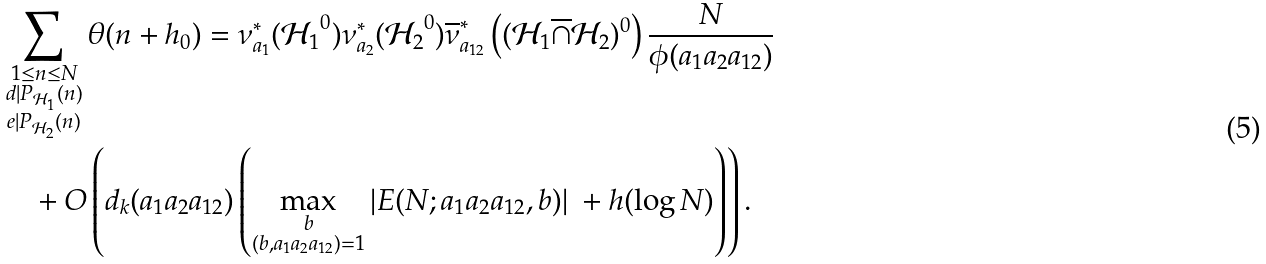Convert formula to latex. <formula><loc_0><loc_0><loc_500><loc_500>& \sum _ { \substack { 1 \leq n \leq N \\ d | P _ { \mathcal { H } _ { 1 } } ( n ) \\ e | P _ { \mathcal { H } _ { 2 } } ( n ) } } \theta ( n + h _ { 0 } ) = \nu _ { a _ { 1 } } ^ { * } ( { \mathcal { H } _ { 1 } } ^ { 0 } ) \nu _ { a _ { 2 } } ^ { * } ( { \mathcal { H } _ { 2 } } ^ { 0 } ) \overline { \nu } _ { a _ { 1 2 } } ^ { * } \left ( ( \mathcal { H } _ { 1 } \overline { \cap } \mathcal { H } _ { 2 } ) ^ { 0 } \right ) \frac { N } { \phi ( a _ { 1 } a _ { 2 } a _ { 1 2 } ) } \\ & \quad + O \left ( d _ { k } ( a _ { 1 } a _ { 2 } a _ { 1 2 } ) \left ( \max _ { \substack { b \\ ( b , a _ { 1 } a _ { 2 } a _ { 1 2 } ) = 1 } } \left | E ( N ; a _ { 1 } a _ { 2 } a _ { 1 2 } , b ) \right | \ + h ( \log N ) \right ) \right ) .</formula> 